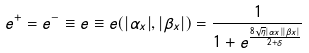<formula> <loc_0><loc_0><loc_500><loc_500>e ^ { + } = e ^ { - } \equiv e \equiv e ( | \alpha _ { x } | , | \beta _ { x } | ) = \frac { 1 } { 1 + e ^ { \frac { 8 \sqrt { \eta } | \alpha _ { x } | | \beta _ { x } | } { 2 + \delta } } }</formula> 